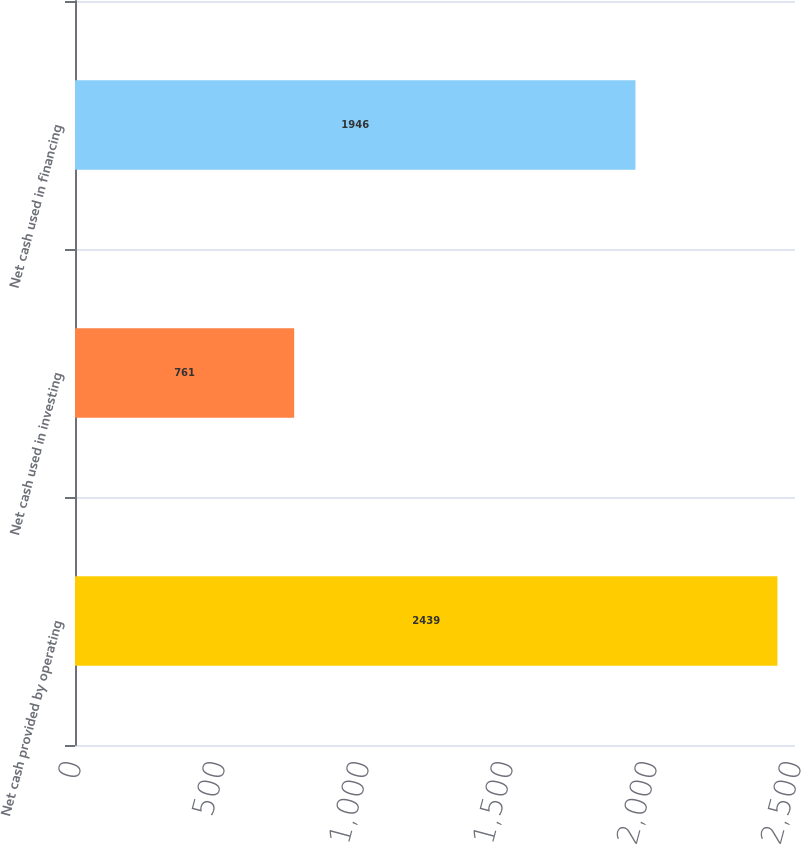Convert chart. <chart><loc_0><loc_0><loc_500><loc_500><bar_chart><fcel>Net cash provided by operating<fcel>Net cash used in investing<fcel>Net cash used in financing<nl><fcel>2439<fcel>761<fcel>1946<nl></chart> 